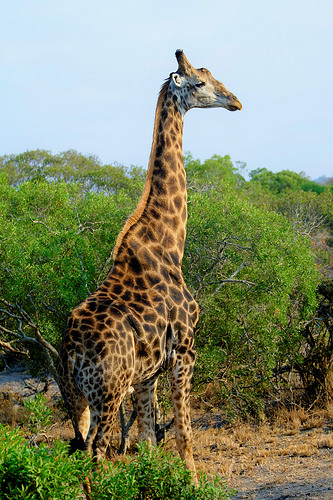<image>
Is the giraffe in the trees? No. The giraffe is not contained within the trees. These objects have a different spatial relationship. Where is the giraffe in relation to the bush? Is it in front of the bush? Yes. The giraffe is positioned in front of the bush, appearing closer to the camera viewpoint. 